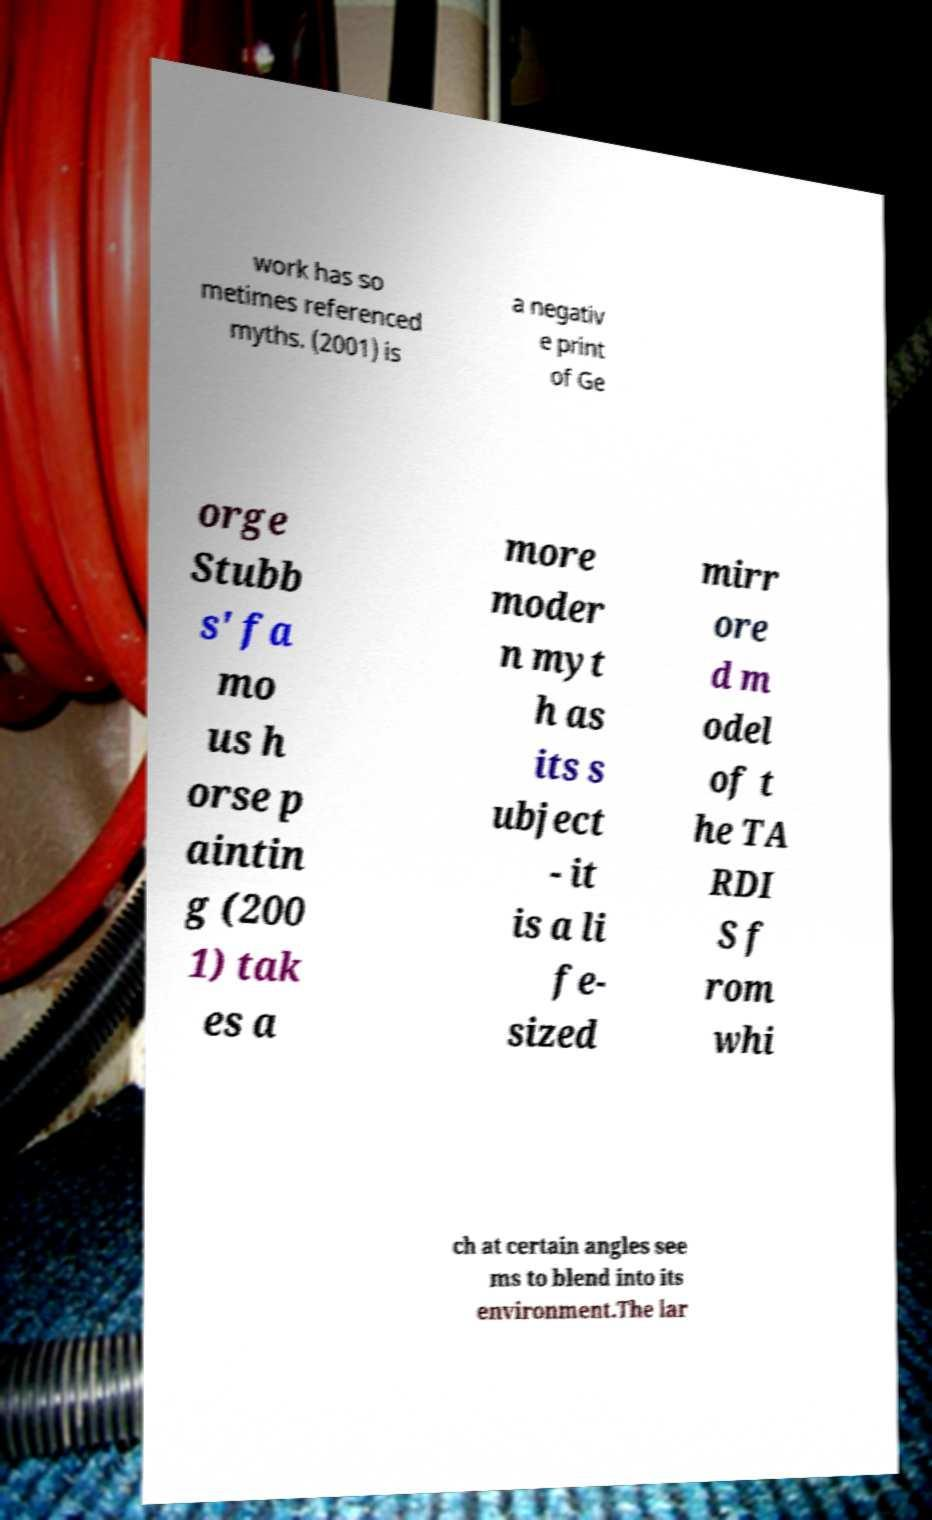There's text embedded in this image that I need extracted. Can you transcribe it verbatim? work has so metimes referenced myths. (2001) is a negativ e print of Ge orge Stubb s' fa mo us h orse p aintin g (200 1) tak es a more moder n myt h as its s ubject - it is a li fe- sized mirr ore d m odel of t he TA RDI S f rom whi ch at certain angles see ms to blend into its environment.The lar 